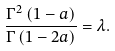<formula> <loc_0><loc_0><loc_500><loc_500>\frac { \Gamma ^ { 2 } \left ( 1 - a \right ) } { \Gamma \left ( 1 - 2 a \right ) } = \lambda .</formula> 